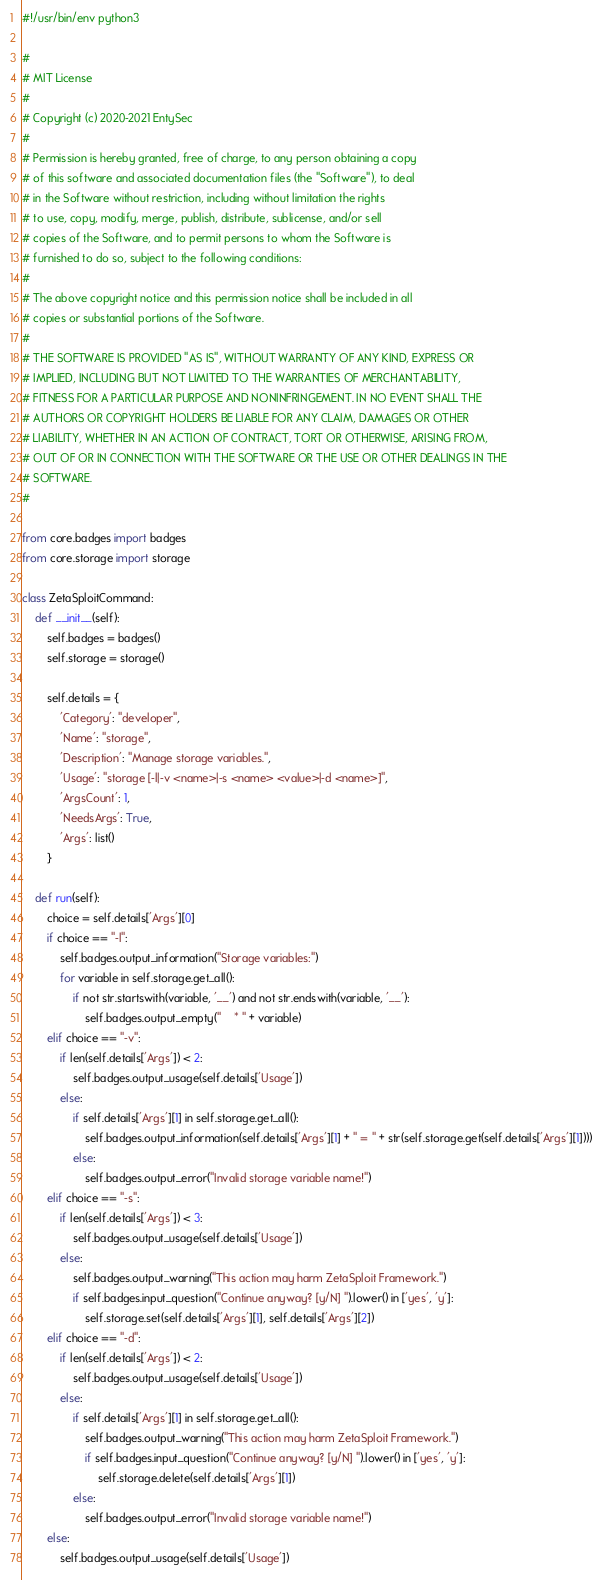Convert code to text. <code><loc_0><loc_0><loc_500><loc_500><_Python_>#!/usr/bin/env python3

#
# MIT License
#
# Copyright (c) 2020-2021 EntySec
#
# Permission is hereby granted, free of charge, to any person obtaining a copy
# of this software and associated documentation files (the "Software"), to deal
# in the Software without restriction, including without limitation the rights
# to use, copy, modify, merge, publish, distribute, sublicense, and/or sell
# copies of the Software, and to permit persons to whom the Software is
# furnished to do so, subject to the following conditions:
#
# The above copyright notice and this permission notice shall be included in all
# copies or substantial portions of the Software.
#
# THE SOFTWARE IS PROVIDED "AS IS", WITHOUT WARRANTY OF ANY KIND, EXPRESS OR
# IMPLIED, INCLUDING BUT NOT LIMITED TO THE WARRANTIES OF MERCHANTABILITY,
# FITNESS FOR A PARTICULAR PURPOSE AND NONINFRINGEMENT. IN NO EVENT SHALL THE
# AUTHORS OR COPYRIGHT HOLDERS BE LIABLE FOR ANY CLAIM, DAMAGES OR OTHER
# LIABILITY, WHETHER IN AN ACTION OF CONTRACT, TORT OR OTHERWISE, ARISING FROM,
# OUT OF OR IN CONNECTION WITH THE SOFTWARE OR THE USE OR OTHER DEALINGS IN THE
# SOFTWARE.
#

from core.badges import badges
from core.storage import storage

class ZetaSploitCommand:
    def __init__(self):
        self.badges = badges()
        self.storage = storage()

        self.details = {
            'Category': "developer",
            'Name': "storage",
            'Description': "Manage storage variables.",
            'Usage': "storage [-l|-v <name>|-s <name> <value>|-d <name>]",
            'ArgsCount': 1,
            'NeedsArgs': True,
            'Args': list()
        }

    def run(self):
        choice = self.details['Args'][0]
        if choice == "-l":
            self.badges.output_information("Storage variables:")
            for variable in self.storage.get_all():
                if not str.startswith(variable, '__') and not str.endswith(variable, '__'):
                    self.badges.output_empty("    * " + variable)
        elif choice == "-v":
            if len(self.details['Args']) < 2:
                self.badges.output_usage(self.details['Usage'])
            else:
                if self.details['Args'][1] in self.storage.get_all():
                    self.badges.output_information(self.details['Args'][1] + " = " + str(self.storage.get(self.details['Args'][1])))
                else:
                    self.badges.output_error("Invalid storage variable name!")
        elif choice == "-s":
            if len(self.details['Args']) < 3:
                self.badges.output_usage(self.details['Usage'])
            else:
                self.badges.output_warning("This action may harm ZetaSploit Framework.")
                if self.badges.input_question("Continue anyway? [y/N] ").lower() in ['yes', 'y']:
                    self.storage.set(self.details['Args'][1], self.details['Args'][2])
        elif choice == "-d":
            if len(self.details['Args']) < 2:
                self.badges.output_usage(self.details['Usage'])
            else:
                if self.details['Args'][1] in self.storage.get_all():
                    self.badges.output_warning("This action may harm ZetaSploit Framework.")
                    if self.badges.input_question("Continue anyway? [y/N] ").lower() in ['yes', 'y']:
                        self.storage.delete(self.details['Args'][1])
                else:
                    self.badges.output_error("Invalid storage variable name!")
        else:
            self.badges.output_usage(self.details['Usage'])
</code> 